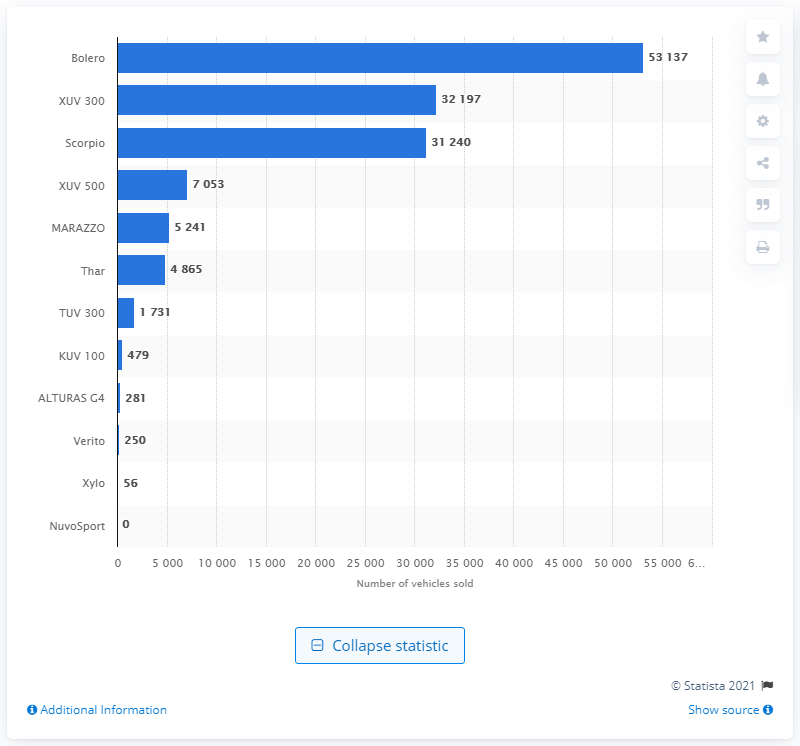Point out several critical features in this image. In 2020, a total of 53,137 units of Mahindra Balero were sold in India. 